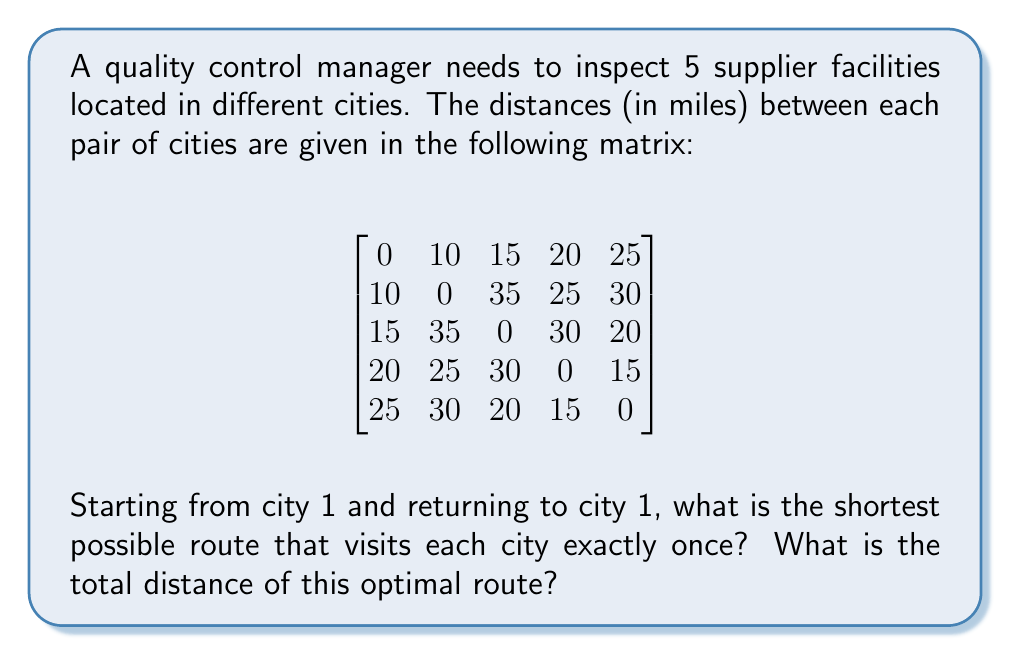Provide a solution to this math problem. To solve this Traveling Salesman Problem (TSP), we'll use the following steps:

1) First, let's list all possible routes starting and ending at city 1:
   1-2-3-4-5-1
   1-2-3-5-4-1
   1-2-4-3-5-1
   1-2-4-5-3-1
   1-2-5-3-4-1
   1-2-5-4-3-1
   1-3-2-4-5-1
   1-3-2-5-4-1
   1-3-4-2-5-1
   1-3-4-5-2-1
   1-3-5-2-4-1
   1-3-5-4-2-1
   ...and so on (there are 24 possible routes in total)

2) For each route, we calculate the total distance:

   For example, let's calculate 1-2-3-4-5-1:
   $10 + 35 + 30 + 15 + 25 = 115$ miles

3) We repeat this process for all 24 routes and keep track of the shortest one.

4) After evaluating all routes, we find that the shortest route is:
   1-2-4-5-3-1

5) Let's verify the distance of this route:
   1 to 2: 10 miles
   2 to 4: 25 miles
   4 to 5: 15 miles
   5 to 3: 20 miles
   3 to 1: 15 miles

   Total: $10 + 25 + 15 + 20 + 15 = 85$ miles

This is indeed the shortest possible route visiting each city once and returning to the starting point.
Answer: The shortest route is 1-2-4-5-3-1, with a total distance of 85 miles. 